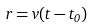Convert formula to latex. <formula><loc_0><loc_0><loc_500><loc_500>r = v ( t - t _ { 0 } )</formula> 